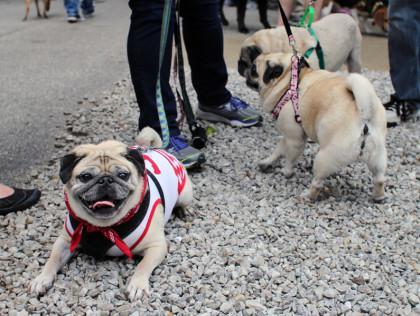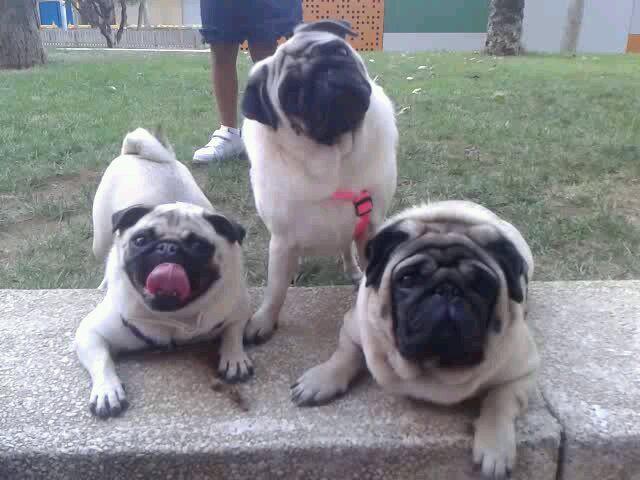The first image is the image on the left, the second image is the image on the right. Given the left and right images, does the statement "Three dogs are in a row, shoulder to shoulder in one of the images." hold true? Answer yes or no. No. The first image is the image on the left, the second image is the image on the right. Examine the images to the left and right. Is the description "One image shows three pugs posed like a conga line, two of them facing another's back with front paws around its midsection." accurate? Answer yes or no. No. 